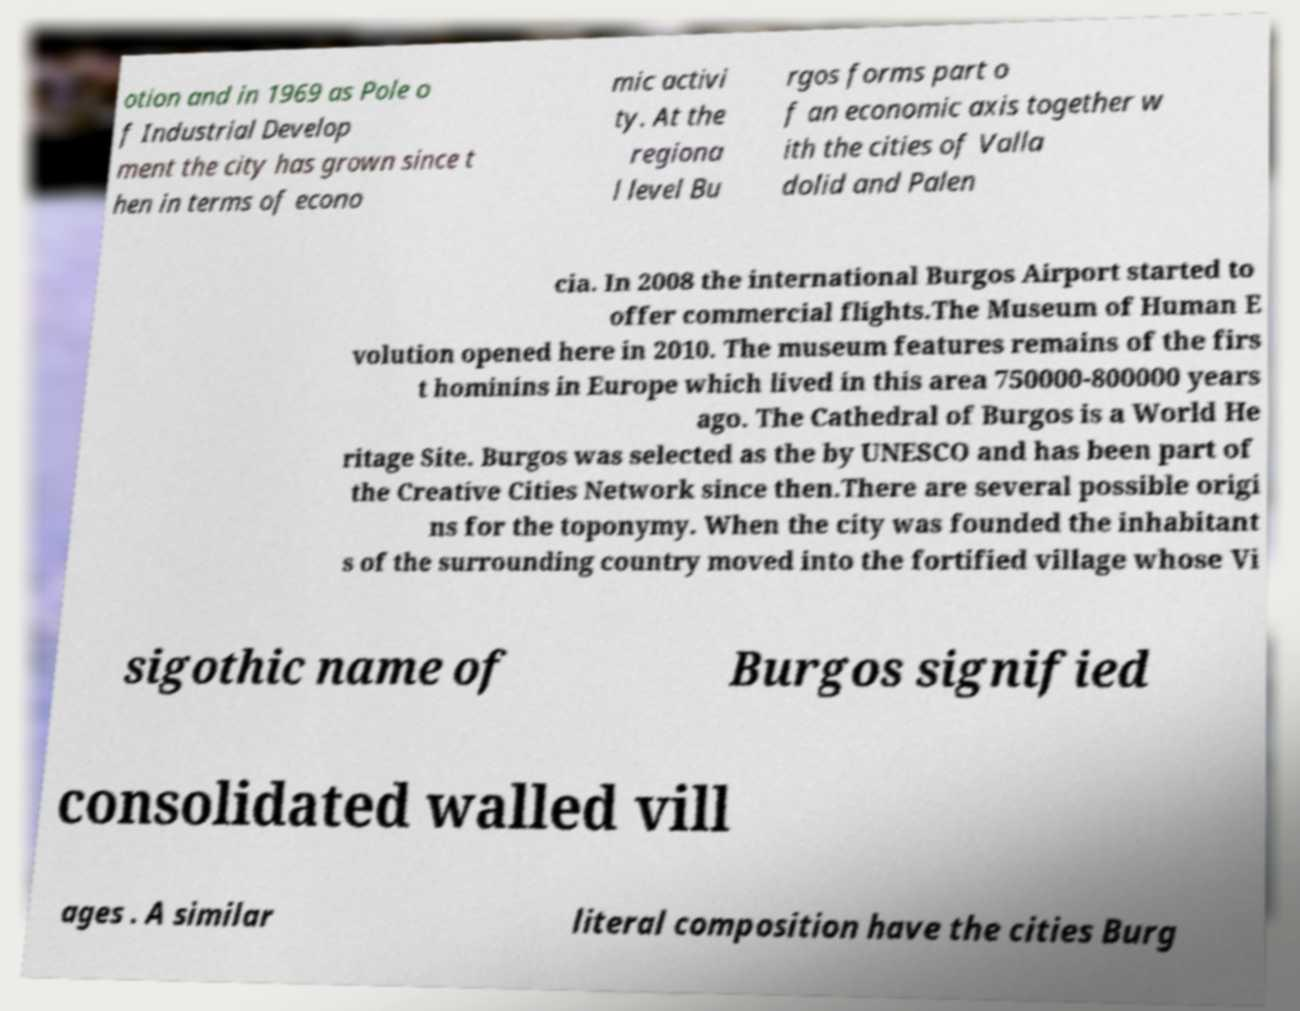For documentation purposes, I need the text within this image transcribed. Could you provide that? otion and in 1969 as Pole o f Industrial Develop ment the city has grown since t hen in terms of econo mic activi ty. At the regiona l level Bu rgos forms part o f an economic axis together w ith the cities of Valla dolid and Palen cia. In 2008 the international Burgos Airport started to offer commercial flights.The Museum of Human E volution opened here in 2010. The museum features remains of the firs t hominins in Europe which lived in this area 750000-800000 years ago. The Cathedral of Burgos is a World He ritage Site. Burgos was selected as the by UNESCO and has been part of the Creative Cities Network since then.There are several possible origi ns for the toponymy. When the city was founded the inhabitant s of the surrounding country moved into the fortified village whose Vi sigothic name of Burgos signified consolidated walled vill ages . A similar literal composition have the cities Burg 